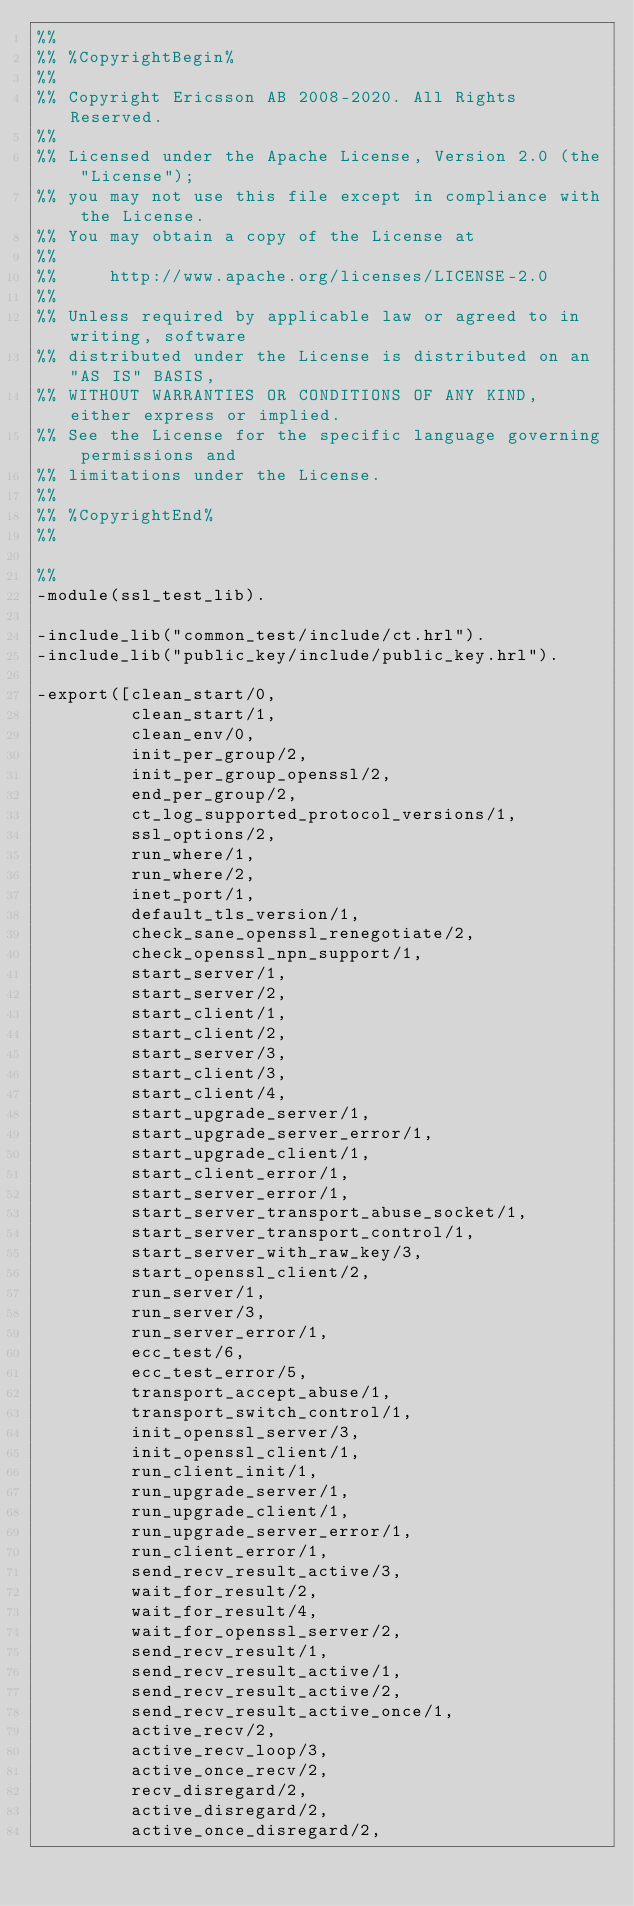Convert code to text. <code><loc_0><loc_0><loc_500><loc_500><_Erlang_>%%
%% %CopyrightBegin%
%%
%% Copyright Ericsson AB 2008-2020. All Rights Reserved.
%%
%% Licensed under the Apache License, Version 2.0 (the "License");
%% you may not use this file except in compliance with the License.
%% You may obtain a copy of the License at
%%
%%     http://www.apache.org/licenses/LICENSE-2.0
%%
%% Unless required by applicable law or agreed to in writing, software
%% distributed under the License is distributed on an "AS IS" BASIS,
%% WITHOUT WARRANTIES OR CONDITIONS OF ANY KIND, either express or implied.
%% See the License for the specific language governing permissions and
%% limitations under the License.
%%
%% %CopyrightEnd%
%%

%%
-module(ssl_test_lib).

-include_lib("common_test/include/ct.hrl").
-include_lib("public_key/include/public_key.hrl").

-export([clean_start/0,
         clean_start/1,
         clean_env/0,
         init_per_group/2,
         init_per_group_openssl/2,
         end_per_group/2,
         ct_log_supported_protocol_versions/1,
         ssl_options/2,
         run_where/1,
         run_where/2,
         inet_port/1,
         default_tls_version/1,
         check_sane_openssl_renegotiate/2,
         check_openssl_npn_support/1,
         start_server/1,
         start_server/2,
         start_client/1,
         start_client/2,
         start_server/3,
         start_client/3,
         start_client/4,
         start_upgrade_server/1,
         start_upgrade_server_error/1,
         start_upgrade_client/1,
         start_client_error/1,
         start_server_error/1,
         start_server_transport_abuse_socket/1,
         start_server_transport_control/1,
         start_server_with_raw_key/3,
         start_openssl_client/2,
         run_server/1,
         run_server/3,
         run_server_error/1,
         ecc_test/6,
         ecc_test_error/5,
         transport_accept_abuse/1,
         transport_switch_control/1,
         init_openssl_server/3,
         init_openssl_client/1,
         run_client_init/1,
         run_upgrade_server/1,
         run_upgrade_client/1,
         run_upgrade_server_error/1,
         run_client_error/1,
         send_recv_result_active/3,
         wait_for_result/2,
         wait_for_result/4,
         wait_for_openssl_server/2,
         send_recv_result/1,
         send_recv_result_active/1,
         send_recv_result_active/2,
         send_recv_result_active_once/1,
         active_recv/2,
         active_recv_loop/3,
         active_once_recv/2,
         recv_disregard/2,
         active_disregard/2,
         active_once_disregard/2,</code> 